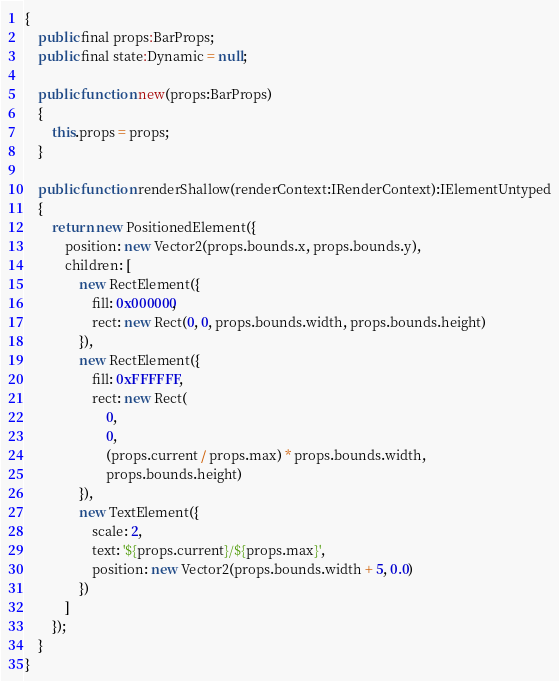<code> <loc_0><loc_0><loc_500><loc_500><_Haxe_>{
    public final props:BarProps;
    public final state:Dynamic = null;

    public function new(props:BarProps)
    {
        this.props = props;
    }

    public function renderShallow(renderContext:IRenderContext):IElementUntyped
    {
        return new PositionedElement({
            position: new Vector2(props.bounds.x, props.bounds.y),
            children: [
                new RectElement({
                    fill: 0x000000,
                    rect: new Rect(0, 0, props.bounds.width, props.bounds.height)
                }),
                new RectElement({
                    fill: 0xFFFFFF,
                    rect: new Rect(
                        0,
                        0,
                        (props.current / props.max) * props.bounds.width,
                        props.bounds.height)
                }),
                new TextElement({
                    scale: 2,
                    text: '${props.current}/${props.max}',
                    position: new Vector2(props.bounds.width + 5, 0.0)
                })
            ]
        });
    }
}</code> 